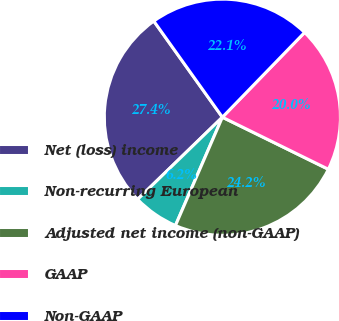Convert chart. <chart><loc_0><loc_0><loc_500><loc_500><pie_chart><fcel>Net (loss) income<fcel>Non-recurring European<fcel>Adjusted net income (non-GAAP)<fcel>GAAP<fcel>Non-GAAP<nl><fcel>27.39%<fcel>6.24%<fcel>24.24%<fcel>20.01%<fcel>22.12%<nl></chart> 